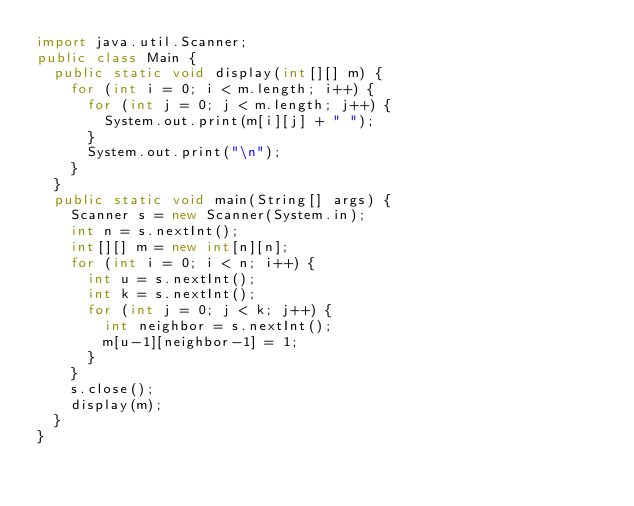Convert code to text. <code><loc_0><loc_0><loc_500><loc_500><_Java_>import java.util.Scanner;
public class Main {
  public static void display(int[][] m) {
    for (int i = 0; i < m.length; i++) {
      for (int j = 0; j < m.length; j++) {
        System.out.print(m[i][j] + " ");
      }
      System.out.print("\n");
    }
  }
  public static void main(String[] args) {
    Scanner s = new Scanner(System.in);
    int n = s.nextInt();
    int[][] m = new int[n][n];
    for (int i = 0; i < n; i++) {
      int u = s.nextInt();
      int k = s.nextInt();
      for (int j = 0; j < k; j++) {
        int neighbor = s.nextInt();
        m[u-1][neighbor-1] = 1;
      }
    }
    s.close();
    display(m);
  }
}

</code> 